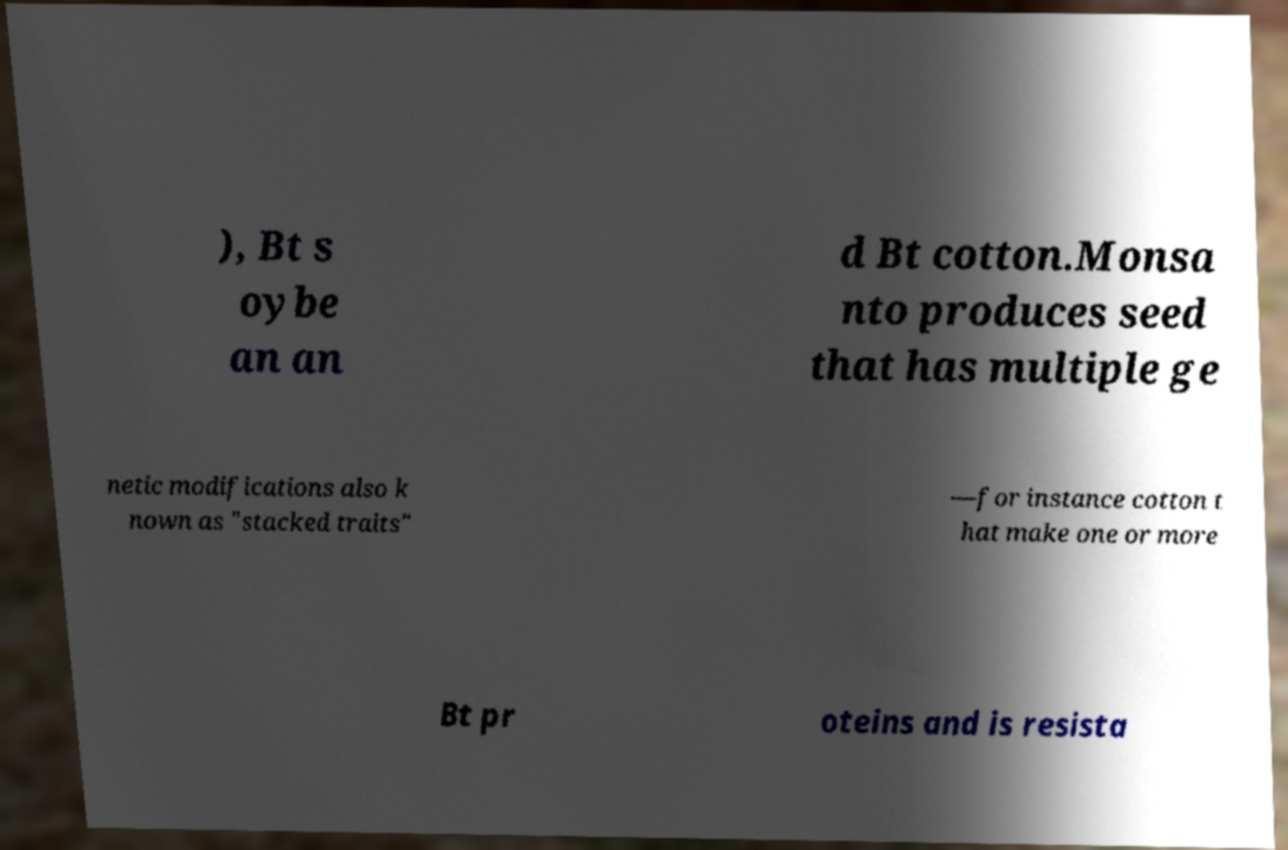Could you extract and type out the text from this image? ), Bt s oybe an an d Bt cotton.Monsa nto produces seed that has multiple ge netic modifications also k nown as "stacked traits" —for instance cotton t hat make one or more Bt pr oteins and is resista 